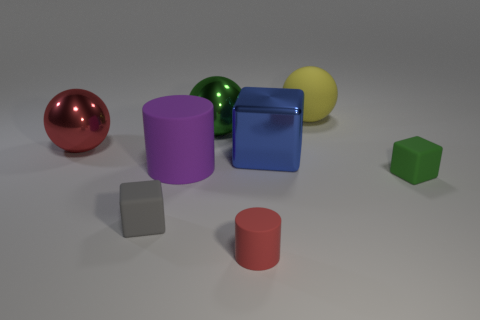There is a ball that is to the left of the metallic ball behind the large red sphere; what is it made of?
Your answer should be very brief. Metal. Are there more tiny red things behind the gray rubber thing than red rubber cylinders?
Ensure brevity in your answer.  No. What number of other objects are there of the same size as the red rubber cylinder?
Your answer should be compact. 2. Does the rubber sphere have the same color as the large cube?
Provide a short and direct response. No. What is the color of the large matte thing in front of the ball that is left of the tiny block left of the green matte block?
Ensure brevity in your answer.  Purple. There is a green metallic thing that is on the right side of the red object that is behind the tiny gray cube; what number of red objects are left of it?
Your answer should be very brief. 1. Are there any other things that are the same color as the large matte sphere?
Provide a succinct answer. No. Do the matte object to the right of the matte sphere and the large red ball have the same size?
Offer a terse response. No. There is a tiny object to the right of the small red cylinder; how many small red cylinders are behind it?
Make the answer very short. 0. Are there any green metal balls in front of the green object that is on the left side of the ball behind the big green object?
Offer a very short reply. No. 